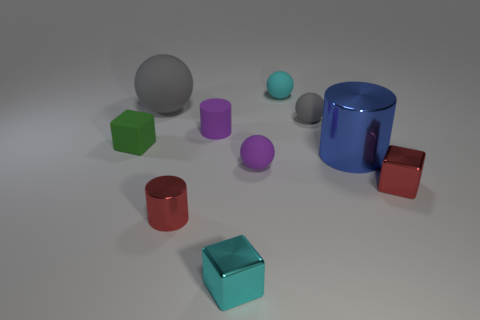Subtract all tiny balls. How many balls are left? 1 Subtract all brown blocks. How many gray spheres are left? 2 Subtract all cyan cubes. How many cubes are left? 2 Subtract 1 cubes. How many cubes are left? 2 Subtract all blocks. How many objects are left? 7 Subtract all blue cylinders. Subtract all brown spheres. How many cylinders are left? 2 Subtract all small gray matte objects. Subtract all tiny green things. How many objects are left? 8 Add 5 green rubber blocks. How many green rubber blocks are left? 6 Add 6 big blue things. How many big blue things exist? 7 Subtract 0 green balls. How many objects are left? 10 